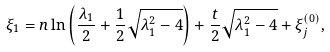Convert formula to latex. <formula><loc_0><loc_0><loc_500><loc_500>\xi _ { 1 } = n \ln \left ( \frac { \lambda _ { 1 } } { 2 } + \frac { 1 } { 2 } \sqrt { \lambda _ { 1 } ^ { 2 } - 4 } \right ) + \frac { t } { 2 } \sqrt { \lambda _ { 1 } ^ { 2 } - 4 } + \xi ^ { ( 0 ) } _ { j } ,</formula> 